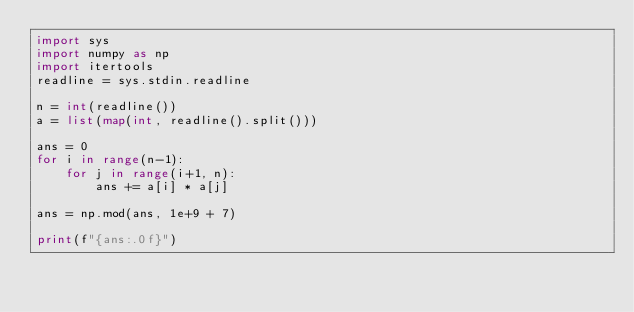<code> <loc_0><loc_0><loc_500><loc_500><_Python_>import sys
import numpy as np
import itertools
readline = sys.stdin.readline

n = int(readline())
a = list(map(int, readline().split()))

ans = 0
for i in range(n-1):
    for j in range(i+1, n):
        ans += a[i] * a[j]

ans = np.mod(ans, 1e+9 + 7)

print(f"{ans:.0f}")</code> 